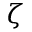<formula> <loc_0><loc_0><loc_500><loc_500>\zeta</formula> 